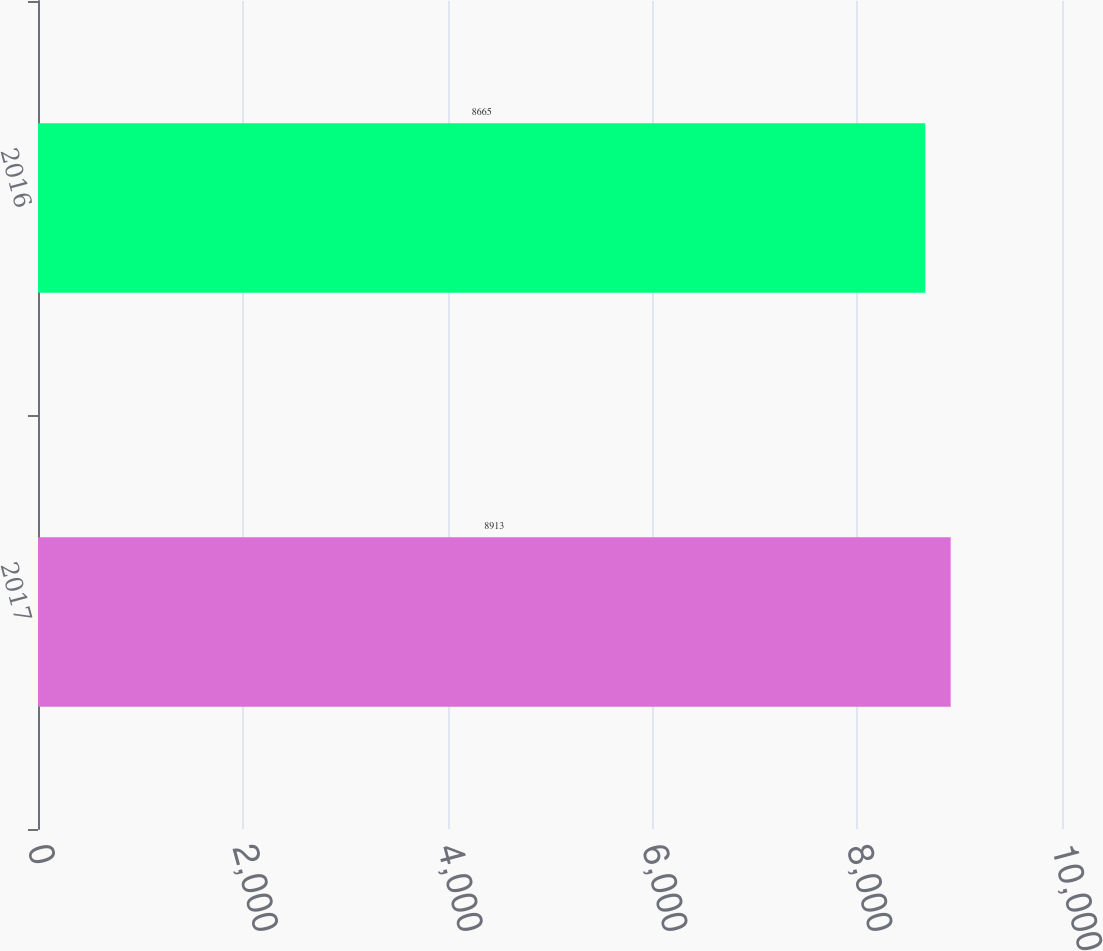Convert chart. <chart><loc_0><loc_0><loc_500><loc_500><bar_chart><fcel>2017<fcel>2016<nl><fcel>8913<fcel>8665<nl></chart> 